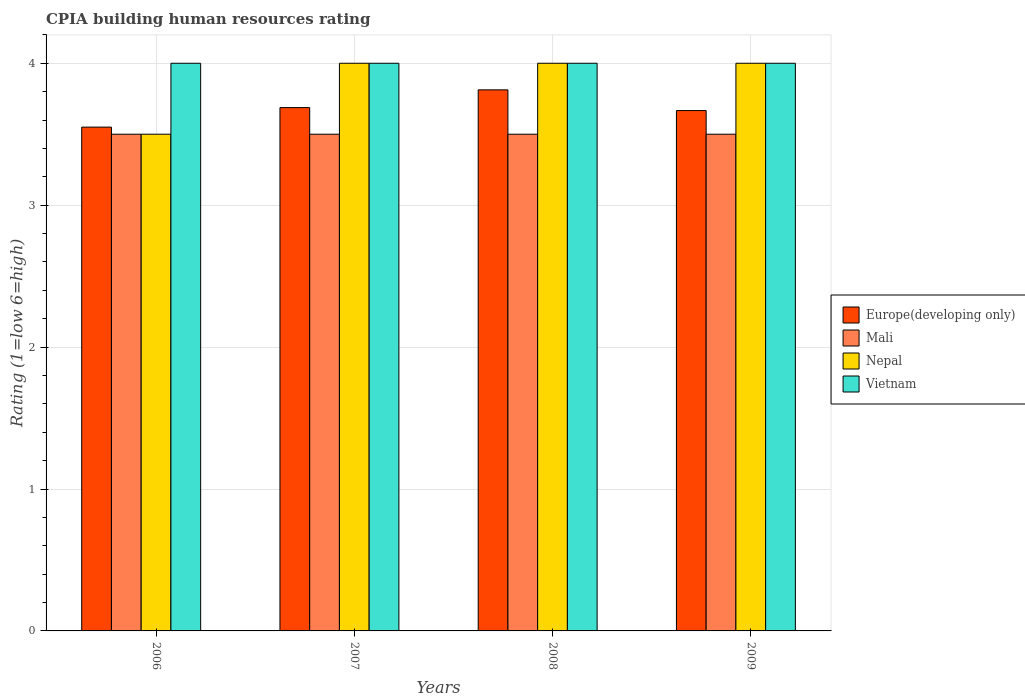How many different coloured bars are there?
Make the answer very short. 4. Are the number of bars per tick equal to the number of legend labels?
Your answer should be compact. Yes. Are the number of bars on each tick of the X-axis equal?
Your answer should be compact. Yes. What is the label of the 2nd group of bars from the left?
Your answer should be compact. 2007. Across all years, what is the maximum CPIA rating in Nepal?
Provide a short and direct response. 4. Across all years, what is the minimum CPIA rating in Nepal?
Your answer should be very brief. 3.5. What is the total CPIA rating in Europe(developing only) in the graph?
Ensure brevity in your answer.  14.72. In how many years, is the CPIA rating in Europe(developing only) greater than 1.4?
Provide a short and direct response. 4. What is the ratio of the CPIA rating in Europe(developing only) in 2006 to that in 2008?
Offer a terse response. 0.93. What is the difference between the highest and the lowest CPIA rating in Nepal?
Your response must be concise. 0.5. Is it the case that in every year, the sum of the CPIA rating in Vietnam and CPIA rating in Nepal is greater than the sum of CPIA rating in Europe(developing only) and CPIA rating in Mali?
Make the answer very short. No. What does the 2nd bar from the left in 2008 represents?
Give a very brief answer. Mali. What does the 2nd bar from the right in 2008 represents?
Your response must be concise. Nepal. How many bars are there?
Give a very brief answer. 16. Are the values on the major ticks of Y-axis written in scientific E-notation?
Your response must be concise. No. Does the graph contain any zero values?
Offer a terse response. No. Where does the legend appear in the graph?
Provide a succinct answer. Center right. What is the title of the graph?
Offer a terse response. CPIA building human resources rating. Does "Luxembourg" appear as one of the legend labels in the graph?
Provide a succinct answer. No. What is the label or title of the X-axis?
Offer a very short reply. Years. What is the label or title of the Y-axis?
Keep it short and to the point. Rating (1=low 6=high). What is the Rating (1=low 6=high) in Europe(developing only) in 2006?
Offer a terse response. 3.55. What is the Rating (1=low 6=high) of Mali in 2006?
Make the answer very short. 3.5. What is the Rating (1=low 6=high) of Vietnam in 2006?
Provide a succinct answer. 4. What is the Rating (1=low 6=high) in Europe(developing only) in 2007?
Provide a succinct answer. 3.69. What is the Rating (1=low 6=high) in Nepal in 2007?
Your response must be concise. 4. What is the Rating (1=low 6=high) in Europe(developing only) in 2008?
Offer a terse response. 3.81. What is the Rating (1=low 6=high) of Nepal in 2008?
Your response must be concise. 4. What is the Rating (1=low 6=high) of Europe(developing only) in 2009?
Your answer should be compact. 3.67. What is the Rating (1=low 6=high) of Mali in 2009?
Ensure brevity in your answer.  3.5. What is the Rating (1=low 6=high) in Vietnam in 2009?
Offer a very short reply. 4. Across all years, what is the maximum Rating (1=low 6=high) in Europe(developing only)?
Ensure brevity in your answer.  3.81. Across all years, what is the maximum Rating (1=low 6=high) of Mali?
Offer a very short reply. 3.5. Across all years, what is the minimum Rating (1=low 6=high) of Europe(developing only)?
Offer a terse response. 3.55. Across all years, what is the minimum Rating (1=low 6=high) in Vietnam?
Your response must be concise. 4. What is the total Rating (1=low 6=high) in Europe(developing only) in the graph?
Give a very brief answer. 14.72. What is the total Rating (1=low 6=high) of Nepal in the graph?
Ensure brevity in your answer.  15.5. What is the total Rating (1=low 6=high) of Vietnam in the graph?
Offer a terse response. 16. What is the difference between the Rating (1=low 6=high) of Europe(developing only) in 2006 and that in 2007?
Your answer should be compact. -0.14. What is the difference between the Rating (1=low 6=high) of Mali in 2006 and that in 2007?
Give a very brief answer. 0. What is the difference between the Rating (1=low 6=high) in Nepal in 2006 and that in 2007?
Provide a short and direct response. -0.5. What is the difference between the Rating (1=low 6=high) in Vietnam in 2006 and that in 2007?
Your response must be concise. 0. What is the difference between the Rating (1=low 6=high) in Europe(developing only) in 2006 and that in 2008?
Offer a very short reply. -0.26. What is the difference between the Rating (1=low 6=high) in Mali in 2006 and that in 2008?
Provide a succinct answer. 0. What is the difference between the Rating (1=low 6=high) of Vietnam in 2006 and that in 2008?
Make the answer very short. 0. What is the difference between the Rating (1=low 6=high) in Europe(developing only) in 2006 and that in 2009?
Your response must be concise. -0.12. What is the difference between the Rating (1=low 6=high) of Mali in 2006 and that in 2009?
Offer a terse response. 0. What is the difference between the Rating (1=low 6=high) of Nepal in 2006 and that in 2009?
Provide a short and direct response. -0.5. What is the difference between the Rating (1=low 6=high) of Vietnam in 2006 and that in 2009?
Ensure brevity in your answer.  0. What is the difference between the Rating (1=low 6=high) in Europe(developing only) in 2007 and that in 2008?
Your answer should be very brief. -0.12. What is the difference between the Rating (1=low 6=high) of Nepal in 2007 and that in 2008?
Your answer should be compact. 0. What is the difference between the Rating (1=low 6=high) in Europe(developing only) in 2007 and that in 2009?
Offer a terse response. 0.02. What is the difference between the Rating (1=low 6=high) of Vietnam in 2007 and that in 2009?
Provide a short and direct response. 0. What is the difference between the Rating (1=low 6=high) of Europe(developing only) in 2008 and that in 2009?
Offer a very short reply. 0.15. What is the difference between the Rating (1=low 6=high) of Nepal in 2008 and that in 2009?
Keep it short and to the point. 0. What is the difference between the Rating (1=low 6=high) of Vietnam in 2008 and that in 2009?
Give a very brief answer. 0. What is the difference between the Rating (1=low 6=high) of Europe(developing only) in 2006 and the Rating (1=low 6=high) of Mali in 2007?
Keep it short and to the point. 0.05. What is the difference between the Rating (1=low 6=high) of Europe(developing only) in 2006 and the Rating (1=low 6=high) of Nepal in 2007?
Make the answer very short. -0.45. What is the difference between the Rating (1=low 6=high) of Europe(developing only) in 2006 and the Rating (1=low 6=high) of Vietnam in 2007?
Give a very brief answer. -0.45. What is the difference between the Rating (1=low 6=high) in Mali in 2006 and the Rating (1=low 6=high) in Nepal in 2007?
Provide a succinct answer. -0.5. What is the difference between the Rating (1=low 6=high) of Mali in 2006 and the Rating (1=low 6=high) of Vietnam in 2007?
Offer a very short reply. -0.5. What is the difference between the Rating (1=low 6=high) in Nepal in 2006 and the Rating (1=low 6=high) in Vietnam in 2007?
Make the answer very short. -0.5. What is the difference between the Rating (1=low 6=high) in Europe(developing only) in 2006 and the Rating (1=low 6=high) in Mali in 2008?
Provide a short and direct response. 0.05. What is the difference between the Rating (1=low 6=high) of Europe(developing only) in 2006 and the Rating (1=low 6=high) of Nepal in 2008?
Make the answer very short. -0.45. What is the difference between the Rating (1=low 6=high) of Europe(developing only) in 2006 and the Rating (1=low 6=high) of Vietnam in 2008?
Keep it short and to the point. -0.45. What is the difference between the Rating (1=low 6=high) of Mali in 2006 and the Rating (1=low 6=high) of Nepal in 2008?
Give a very brief answer. -0.5. What is the difference between the Rating (1=low 6=high) in Mali in 2006 and the Rating (1=low 6=high) in Vietnam in 2008?
Give a very brief answer. -0.5. What is the difference between the Rating (1=low 6=high) in Europe(developing only) in 2006 and the Rating (1=low 6=high) in Mali in 2009?
Your response must be concise. 0.05. What is the difference between the Rating (1=low 6=high) of Europe(developing only) in 2006 and the Rating (1=low 6=high) of Nepal in 2009?
Offer a very short reply. -0.45. What is the difference between the Rating (1=low 6=high) in Europe(developing only) in 2006 and the Rating (1=low 6=high) in Vietnam in 2009?
Ensure brevity in your answer.  -0.45. What is the difference between the Rating (1=low 6=high) of Mali in 2006 and the Rating (1=low 6=high) of Nepal in 2009?
Provide a succinct answer. -0.5. What is the difference between the Rating (1=low 6=high) of Nepal in 2006 and the Rating (1=low 6=high) of Vietnam in 2009?
Offer a terse response. -0.5. What is the difference between the Rating (1=low 6=high) of Europe(developing only) in 2007 and the Rating (1=low 6=high) of Mali in 2008?
Your response must be concise. 0.19. What is the difference between the Rating (1=low 6=high) of Europe(developing only) in 2007 and the Rating (1=low 6=high) of Nepal in 2008?
Offer a very short reply. -0.31. What is the difference between the Rating (1=low 6=high) of Europe(developing only) in 2007 and the Rating (1=low 6=high) of Vietnam in 2008?
Offer a terse response. -0.31. What is the difference between the Rating (1=low 6=high) in Mali in 2007 and the Rating (1=low 6=high) in Vietnam in 2008?
Your response must be concise. -0.5. What is the difference between the Rating (1=low 6=high) in Nepal in 2007 and the Rating (1=low 6=high) in Vietnam in 2008?
Your answer should be very brief. 0. What is the difference between the Rating (1=low 6=high) of Europe(developing only) in 2007 and the Rating (1=low 6=high) of Mali in 2009?
Your answer should be compact. 0.19. What is the difference between the Rating (1=low 6=high) of Europe(developing only) in 2007 and the Rating (1=low 6=high) of Nepal in 2009?
Your answer should be compact. -0.31. What is the difference between the Rating (1=low 6=high) of Europe(developing only) in 2007 and the Rating (1=low 6=high) of Vietnam in 2009?
Provide a short and direct response. -0.31. What is the difference between the Rating (1=low 6=high) in Mali in 2007 and the Rating (1=low 6=high) in Vietnam in 2009?
Ensure brevity in your answer.  -0.5. What is the difference between the Rating (1=low 6=high) in Nepal in 2007 and the Rating (1=low 6=high) in Vietnam in 2009?
Provide a short and direct response. 0. What is the difference between the Rating (1=low 6=high) in Europe(developing only) in 2008 and the Rating (1=low 6=high) in Mali in 2009?
Give a very brief answer. 0.31. What is the difference between the Rating (1=low 6=high) in Europe(developing only) in 2008 and the Rating (1=low 6=high) in Nepal in 2009?
Ensure brevity in your answer.  -0.19. What is the difference between the Rating (1=low 6=high) in Europe(developing only) in 2008 and the Rating (1=low 6=high) in Vietnam in 2009?
Give a very brief answer. -0.19. What is the average Rating (1=low 6=high) in Europe(developing only) per year?
Keep it short and to the point. 3.68. What is the average Rating (1=low 6=high) of Mali per year?
Your answer should be compact. 3.5. What is the average Rating (1=low 6=high) of Nepal per year?
Your answer should be compact. 3.88. In the year 2006, what is the difference between the Rating (1=low 6=high) in Europe(developing only) and Rating (1=low 6=high) in Nepal?
Your response must be concise. 0.05. In the year 2006, what is the difference between the Rating (1=low 6=high) of Europe(developing only) and Rating (1=low 6=high) of Vietnam?
Your response must be concise. -0.45. In the year 2006, what is the difference between the Rating (1=low 6=high) in Mali and Rating (1=low 6=high) in Nepal?
Offer a terse response. 0. In the year 2007, what is the difference between the Rating (1=low 6=high) of Europe(developing only) and Rating (1=low 6=high) of Mali?
Offer a terse response. 0.19. In the year 2007, what is the difference between the Rating (1=low 6=high) in Europe(developing only) and Rating (1=low 6=high) in Nepal?
Provide a succinct answer. -0.31. In the year 2007, what is the difference between the Rating (1=low 6=high) of Europe(developing only) and Rating (1=low 6=high) of Vietnam?
Offer a very short reply. -0.31. In the year 2007, what is the difference between the Rating (1=low 6=high) in Mali and Rating (1=low 6=high) in Nepal?
Keep it short and to the point. -0.5. In the year 2007, what is the difference between the Rating (1=low 6=high) of Mali and Rating (1=low 6=high) of Vietnam?
Offer a terse response. -0.5. In the year 2007, what is the difference between the Rating (1=low 6=high) of Nepal and Rating (1=low 6=high) of Vietnam?
Ensure brevity in your answer.  0. In the year 2008, what is the difference between the Rating (1=low 6=high) of Europe(developing only) and Rating (1=low 6=high) of Mali?
Your answer should be very brief. 0.31. In the year 2008, what is the difference between the Rating (1=low 6=high) in Europe(developing only) and Rating (1=low 6=high) in Nepal?
Your answer should be compact. -0.19. In the year 2008, what is the difference between the Rating (1=low 6=high) in Europe(developing only) and Rating (1=low 6=high) in Vietnam?
Give a very brief answer. -0.19. In the year 2009, what is the difference between the Rating (1=low 6=high) in Mali and Rating (1=low 6=high) in Nepal?
Offer a very short reply. -0.5. What is the ratio of the Rating (1=low 6=high) of Europe(developing only) in 2006 to that in 2007?
Offer a terse response. 0.96. What is the ratio of the Rating (1=low 6=high) of Nepal in 2006 to that in 2007?
Ensure brevity in your answer.  0.88. What is the ratio of the Rating (1=low 6=high) in Europe(developing only) in 2006 to that in 2008?
Offer a very short reply. 0.93. What is the ratio of the Rating (1=low 6=high) of Mali in 2006 to that in 2008?
Offer a very short reply. 1. What is the ratio of the Rating (1=low 6=high) in Europe(developing only) in 2006 to that in 2009?
Your answer should be very brief. 0.97. What is the ratio of the Rating (1=low 6=high) in Europe(developing only) in 2007 to that in 2008?
Give a very brief answer. 0.97. What is the ratio of the Rating (1=low 6=high) of Mali in 2007 to that in 2008?
Your response must be concise. 1. What is the ratio of the Rating (1=low 6=high) in Nepal in 2007 to that in 2009?
Offer a very short reply. 1. What is the ratio of the Rating (1=low 6=high) of Europe(developing only) in 2008 to that in 2009?
Offer a terse response. 1.04. What is the ratio of the Rating (1=low 6=high) of Vietnam in 2008 to that in 2009?
Offer a terse response. 1. What is the difference between the highest and the second highest Rating (1=low 6=high) of Europe(developing only)?
Provide a succinct answer. 0.12. What is the difference between the highest and the second highest Rating (1=low 6=high) of Mali?
Your answer should be very brief. 0. What is the difference between the highest and the second highest Rating (1=low 6=high) in Nepal?
Make the answer very short. 0. What is the difference between the highest and the lowest Rating (1=low 6=high) of Europe(developing only)?
Your answer should be compact. 0.26. What is the difference between the highest and the lowest Rating (1=low 6=high) in Mali?
Your response must be concise. 0. What is the difference between the highest and the lowest Rating (1=low 6=high) in Nepal?
Your answer should be compact. 0.5. 